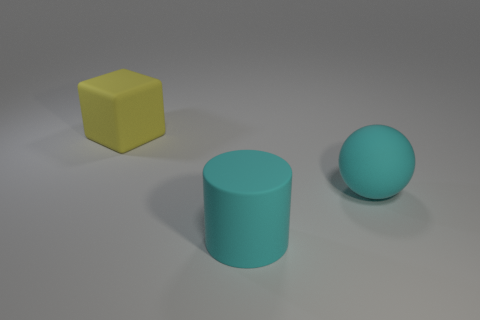Add 3 big yellow objects. How many objects exist? 6 Subtract all cylinders. How many objects are left? 2 Subtract all big cubes. Subtract all cyan cylinders. How many objects are left? 1 Add 3 big matte spheres. How many big matte spheres are left? 4 Add 2 large cylinders. How many large cylinders exist? 3 Subtract 0 green blocks. How many objects are left? 3 